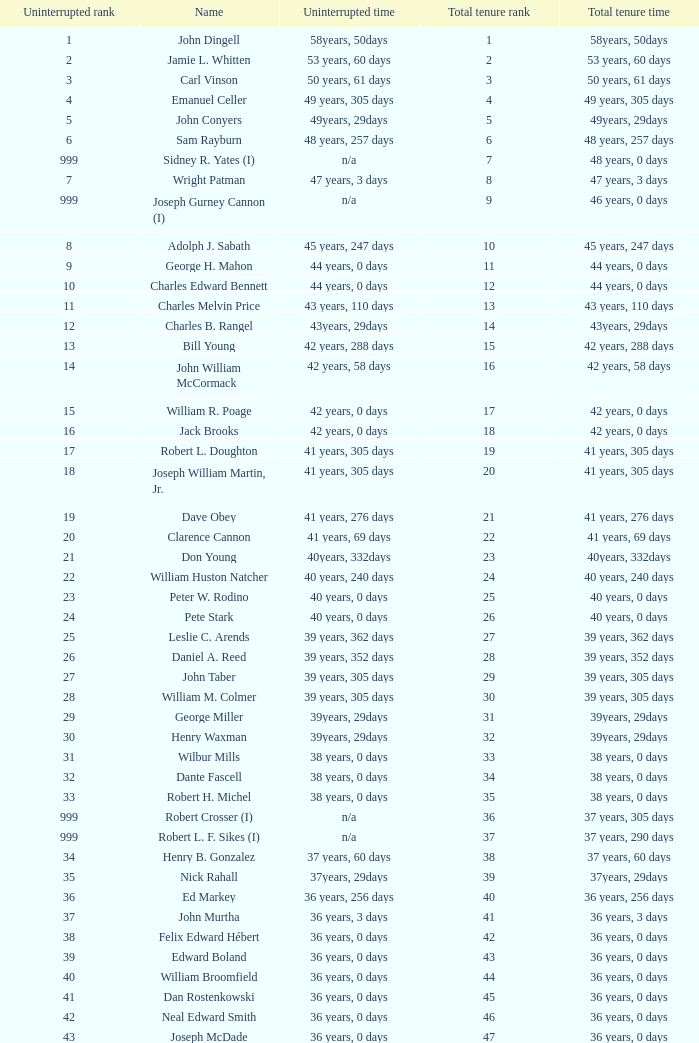Who has a total tenure time and uninterrupted time of 36 years, 0 days, as well as a total tenure rank of 49? James Oberstar. 